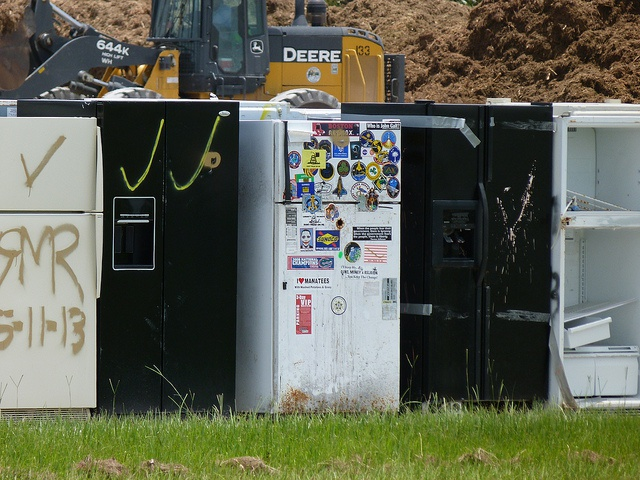Describe the objects in this image and their specific colors. I can see refrigerator in gray, lightgray, and darkgray tones, refrigerator in gray, black, darkgreen, and purple tones, refrigerator in gray, black, darkgreen, and purple tones, refrigerator in gray, lightgray, and darkgray tones, and refrigerator in gray, darkgray, and lightgray tones in this image. 